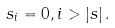Convert formula to latex. <formula><loc_0><loc_0><loc_500><loc_500>s _ { i } = 0 , i > \left | s \right | .</formula> 